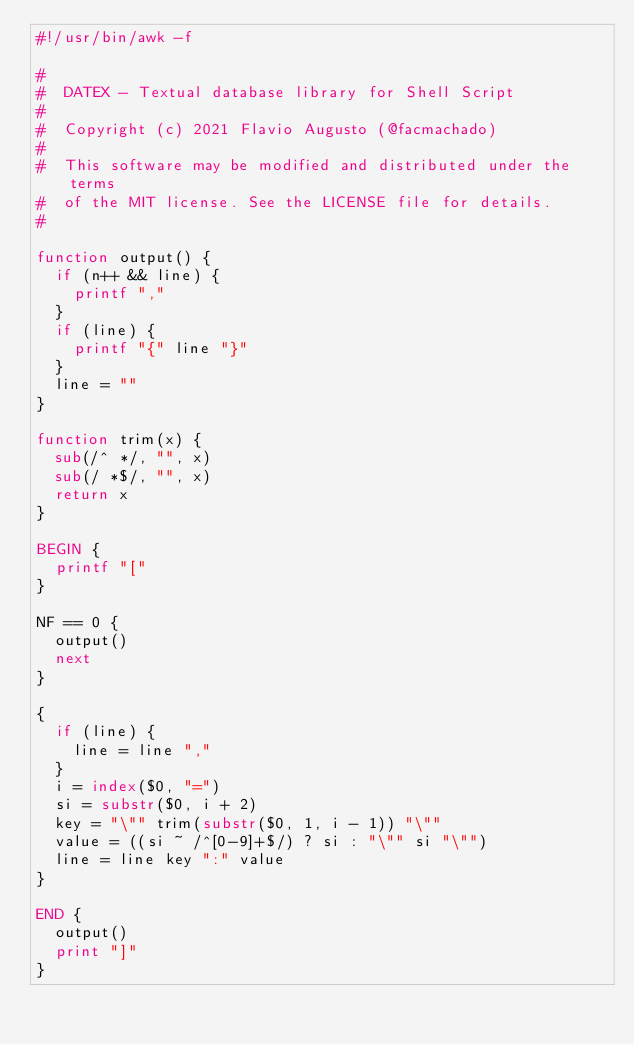<code> <loc_0><loc_0><loc_500><loc_500><_Awk_>#!/usr/bin/awk -f

#
#  DATEX - Textual database library for Shell Script
#
#  Copyright (c) 2021 Flavio Augusto (@facmachado)
#
#  This software may be modified and distributed under the terms
#  of the MIT license. See the LICENSE file for details.
#

function output() {
  if (n++ && line) {
    printf ","
  }
  if (line) {
    printf "{" line "}"
  }
  line = ""
}

function trim(x) {
  sub(/^ */, "", x)
  sub(/ *$/, "", x)
  return x
}

BEGIN {
  printf "["
}

NF == 0 {
  output()
  next
}

{
  if (line) {
    line = line ","
  }
  i = index($0, "=")
  si = substr($0, i + 2)
  key = "\"" trim(substr($0, 1, i - 1)) "\""
  value = ((si ~ /^[0-9]+$/) ? si : "\"" si "\"")
  line = line key ":" value
}

END {
  output()
  print "]"
}
</code> 